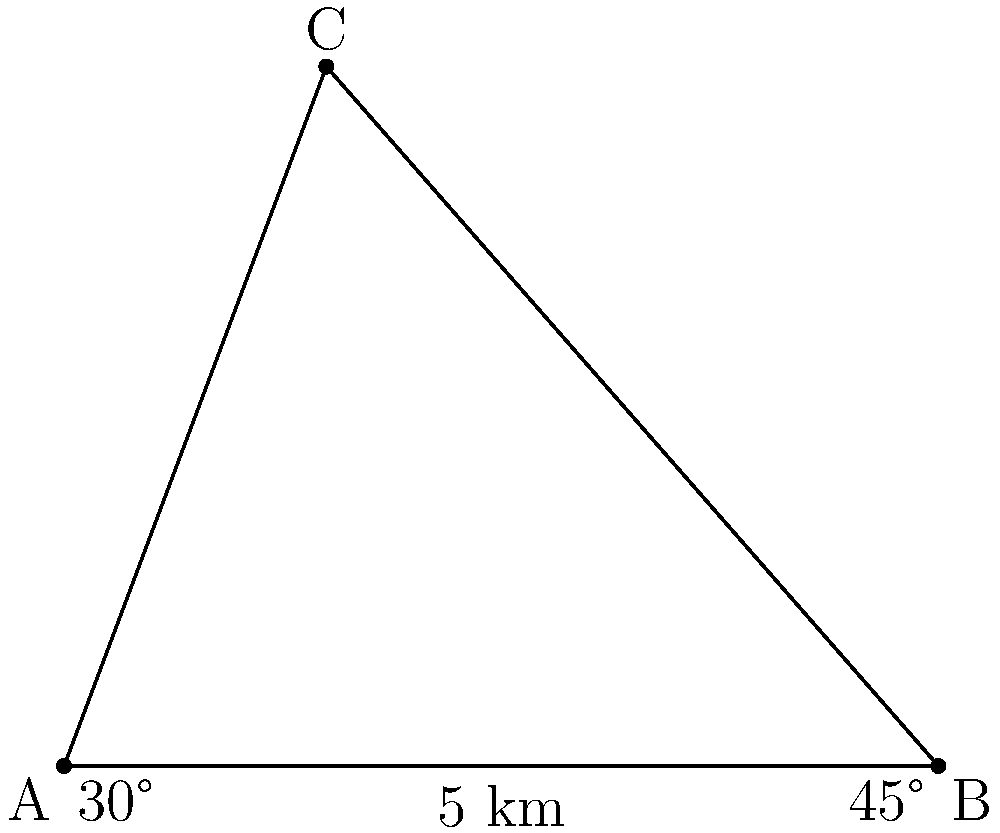Two ships, A and B, are positioned 5 km apart along a straight coastline. A third ship, C, is observed offshore. The angle between the line of sight from ship A to ship C and the coastline is 30°, while the angle between the line of sight from ship B to ship C and the coastline is 45°. Using triangulation, determine the distance between ship A and ship C. How might this scenario relate to organizational leadership and team coordination in a maritime environment? Let's solve this problem step-by-step using trigonometry:

1) First, we identify the triangle formed by the three ships: ABC.

2) We know the distance between A and B (5 km) and two angles:
   - Angle CAB = 30°
   - Angle CBA = 45°

3) To find the distance AC, we can use the sine law:

   $$\frac{AC}{\sin(45°)} = \frac{5}{\sin(180° - 30° - 45°)}$$

4) Simplify the right side:
   $$\frac{AC}{\sin(45°)} = \frac{5}{\sin(105°)}$$

5) Cross multiply:
   $$AC \cdot \sin(105°) = 5 \cdot \sin(45°)$$

6) Solve for AC:
   $$AC = \frac{5 \cdot \sin(45°)}{\sin(105°)}$$

7) Calculate (you can use a calculator):
   $$AC \approx 4.77 \text{ km}$$

Relating to organizational leadership:
This scenario demonstrates the importance of triangulation in both literal and metaphorical senses. In leadership, gathering information from multiple perspectives (like the two observation points in the problem) can lead to more accurate assessments and decision-making. Just as the ships coordinate to determine position, leaders must coordinate team efforts and synthesize diverse inputs to navigate complex organizational challenges.
Answer: 4.77 km 